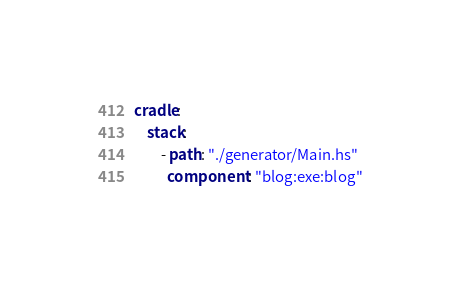<code> <loc_0><loc_0><loc_500><loc_500><_YAML_>cradle:
    stack:
        - path: "./generator/Main.hs"
          component: "blog:exe:blog"
</code> 